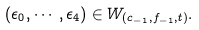Convert formula to latex. <formula><loc_0><loc_0><loc_500><loc_500>( \epsilon _ { 0 } , \cdots , \epsilon _ { 4 } ) \in W _ { ( c _ { - 1 } , f _ { - 1 } , t ) } .</formula> 